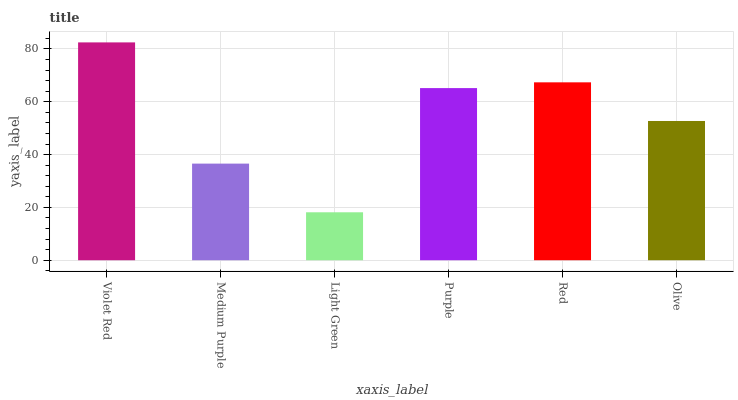Is Light Green the minimum?
Answer yes or no. Yes. Is Violet Red the maximum?
Answer yes or no. Yes. Is Medium Purple the minimum?
Answer yes or no. No. Is Medium Purple the maximum?
Answer yes or no. No. Is Violet Red greater than Medium Purple?
Answer yes or no. Yes. Is Medium Purple less than Violet Red?
Answer yes or no. Yes. Is Medium Purple greater than Violet Red?
Answer yes or no. No. Is Violet Red less than Medium Purple?
Answer yes or no. No. Is Purple the high median?
Answer yes or no. Yes. Is Olive the low median?
Answer yes or no. Yes. Is Violet Red the high median?
Answer yes or no. No. Is Violet Red the low median?
Answer yes or no. No. 